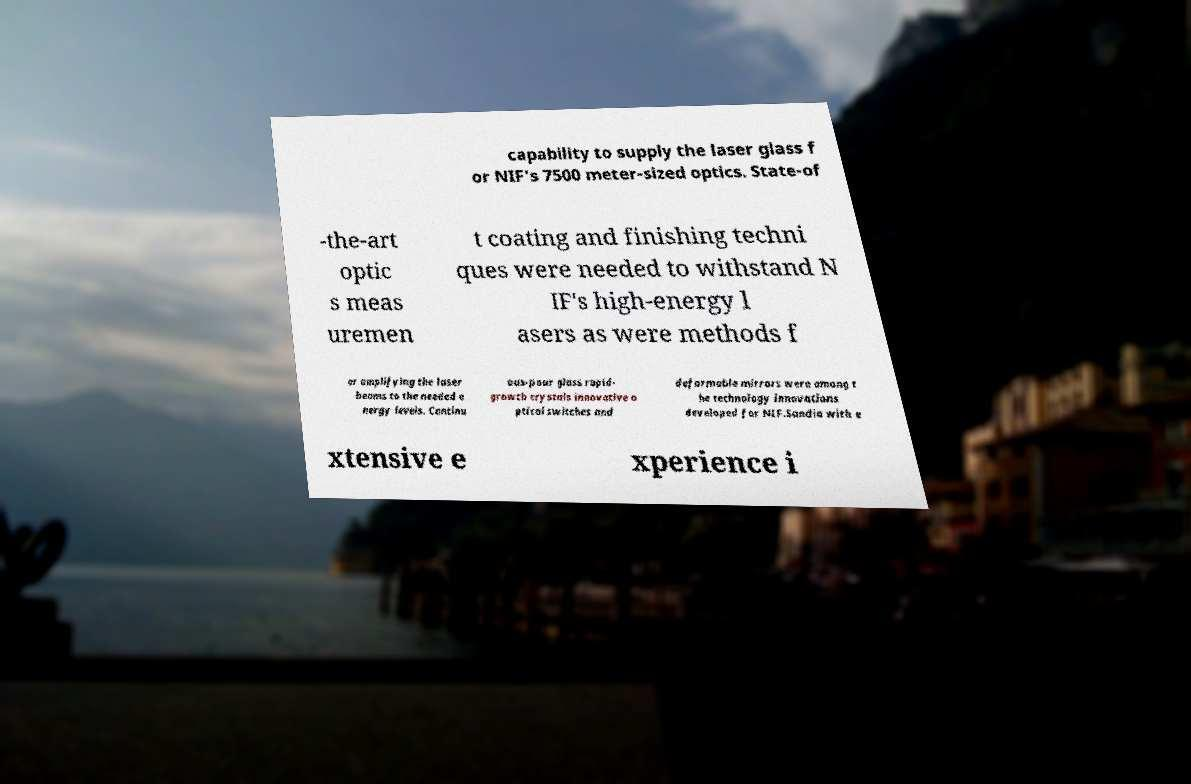Can you read and provide the text displayed in the image?This photo seems to have some interesting text. Can you extract and type it out for me? capability to supply the laser glass f or NIF's 7500 meter-sized optics. State-of -the-art optic s meas uremen t coating and finishing techni ques were needed to withstand N IF's high-energy l asers as were methods f or amplifying the laser beams to the needed e nergy levels. Continu ous-pour glass rapid- growth crystals innovative o ptical switches and deformable mirrors were among t he technology innovations developed for NIF.Sandia with e xtensive e xperience i 